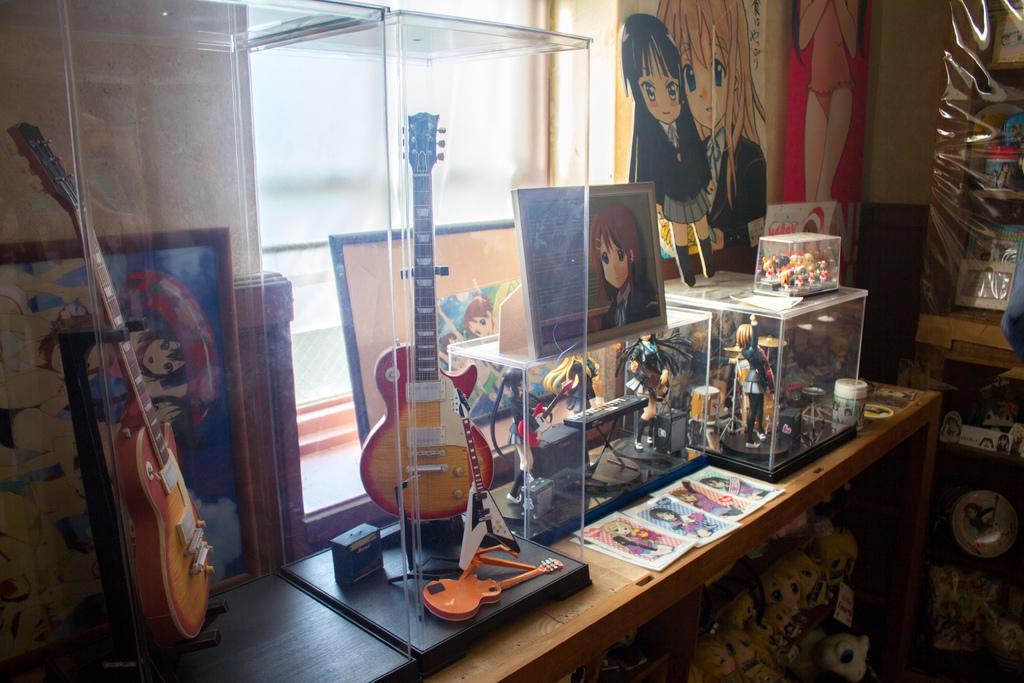Please provide a concise description of this image. In this picture we can see a table and on table we have guitars in glass and some toys inside the glasses and above the glass we have frame and box and in the background we can see wall with cartoon paintings and under the table also we have rack full of toys. 